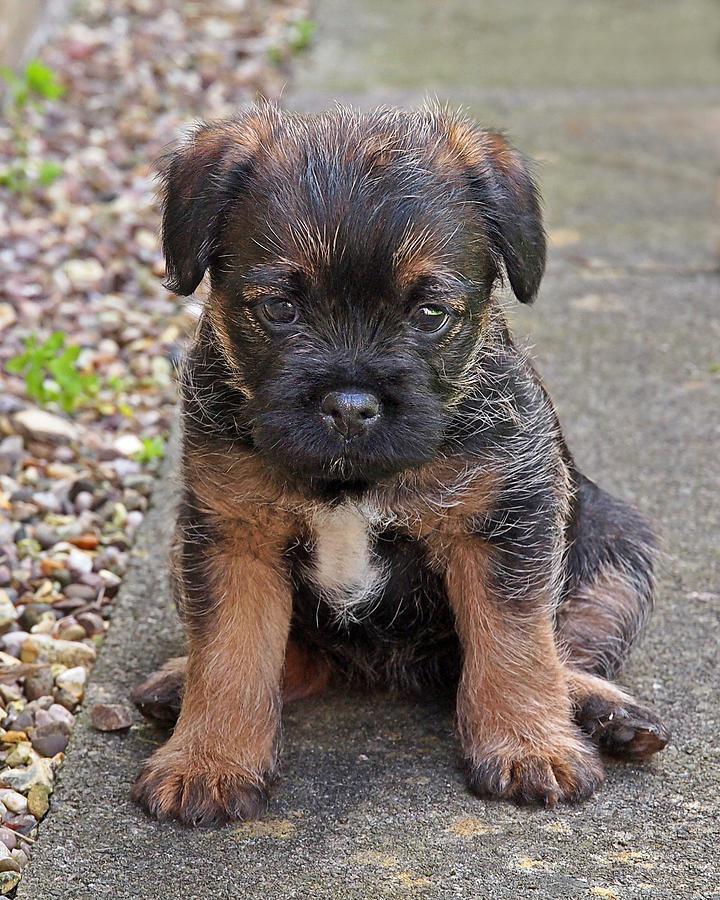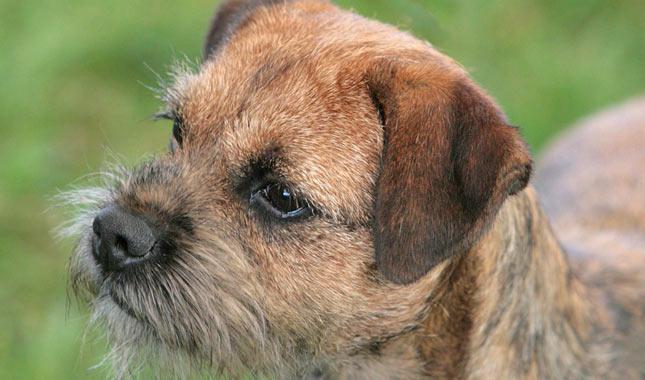The first image is the image on the left, the second image is the image on the right. Analyze the images presented: Is the assertion "There are two dogs wearing a collar." valid? Answer yes or no. No. 